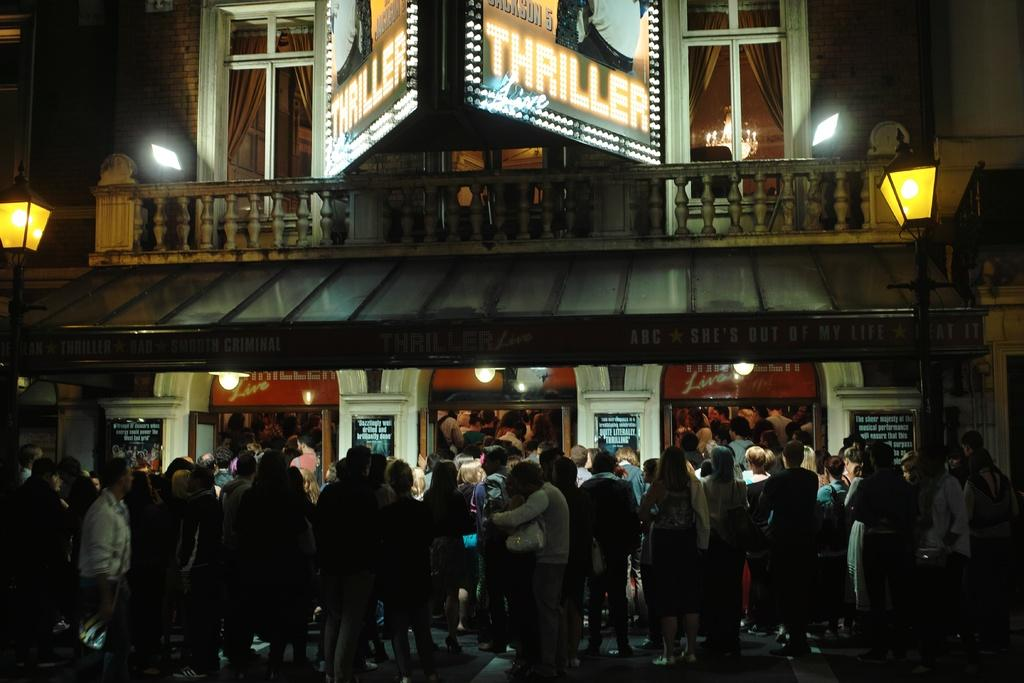Provide a one-sentence caption for the provided image. The large crowd was there to see "Thriller" live. 